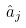<formula> <loc_0><loc_0><loc_500><loc_500>\hat { a } _ { j }</formula> 